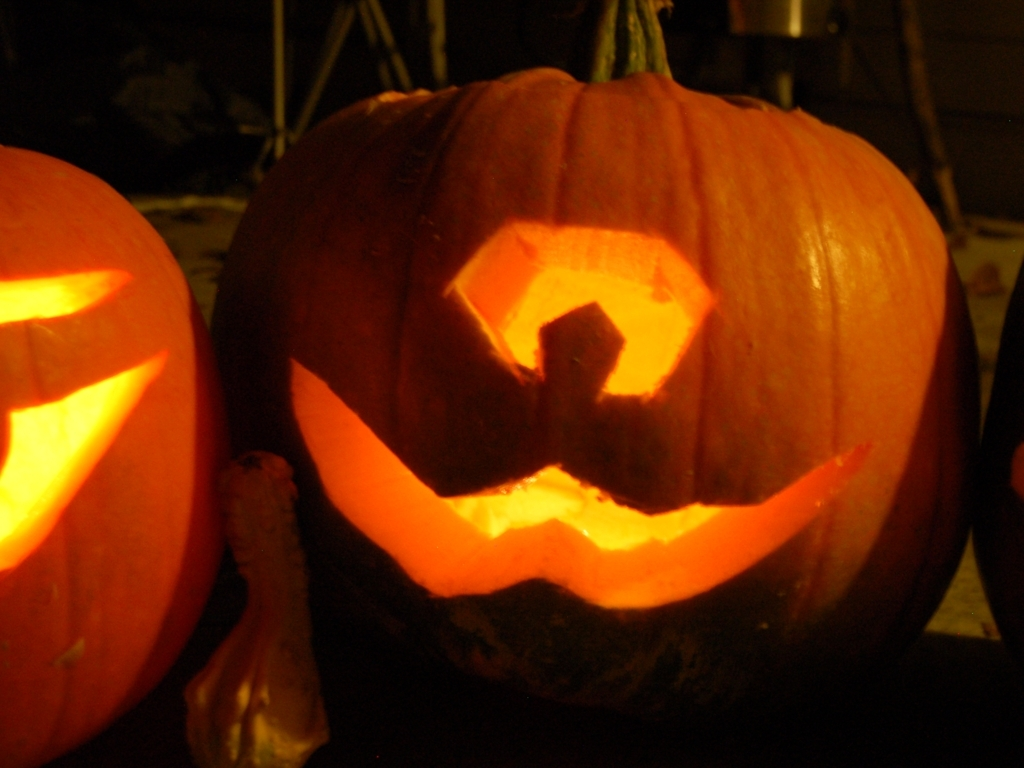Can you describe the carving style on this pumpkin? The pumpkin carving is simplistic with a traditional jack-o'-lantern design, featuring triangular eyes and a crescent-shaped mouth, giving it a playful and somewhat mischievous expression. 